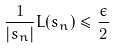<formula> <loc_0><loc_0><loc_500><loc_500>\frac { 1 } { | s _ { n } | } L ( s _ { n } ) \leq \frac { \epsilon } { 2 }</formula> 